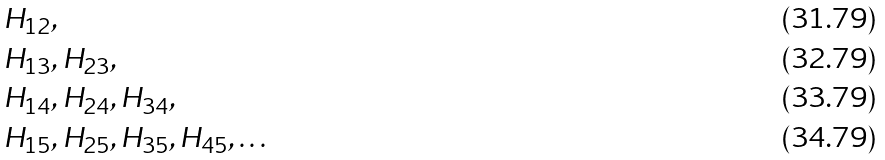Convert formula to latex. <formula><loc_0><loc_0><loc_500><loc_500>& H _ { 1 2 } , \\ & H _ { 1 3 } , H _ { 2 3 } , \\ & H _ { 1 4 } , H _ { 2 4 } , H _ { 3 4 } , \\ & H _ { 1 5 } , H _ { 2 5 } , H _ { 3 5 } , H _ { 4 5 } , \dots</formula> 